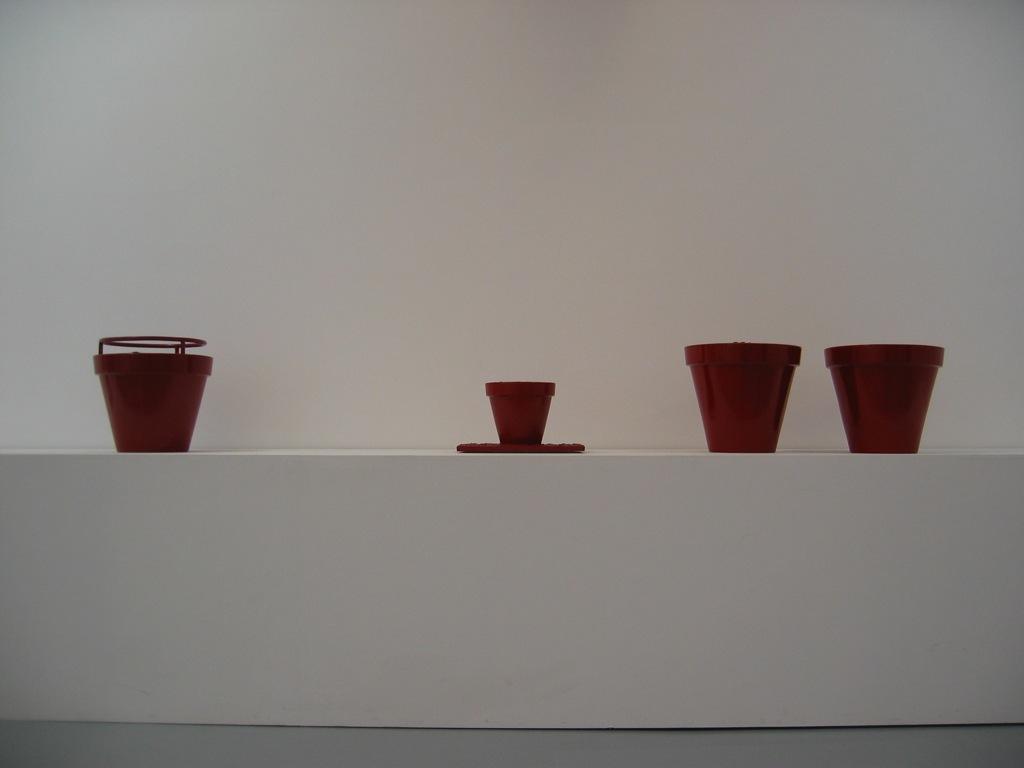Can you describe this image briefly? In this picture I can observe brown color plant pots. I can observe two different sizes of plant pots. In the background there is a wall. 